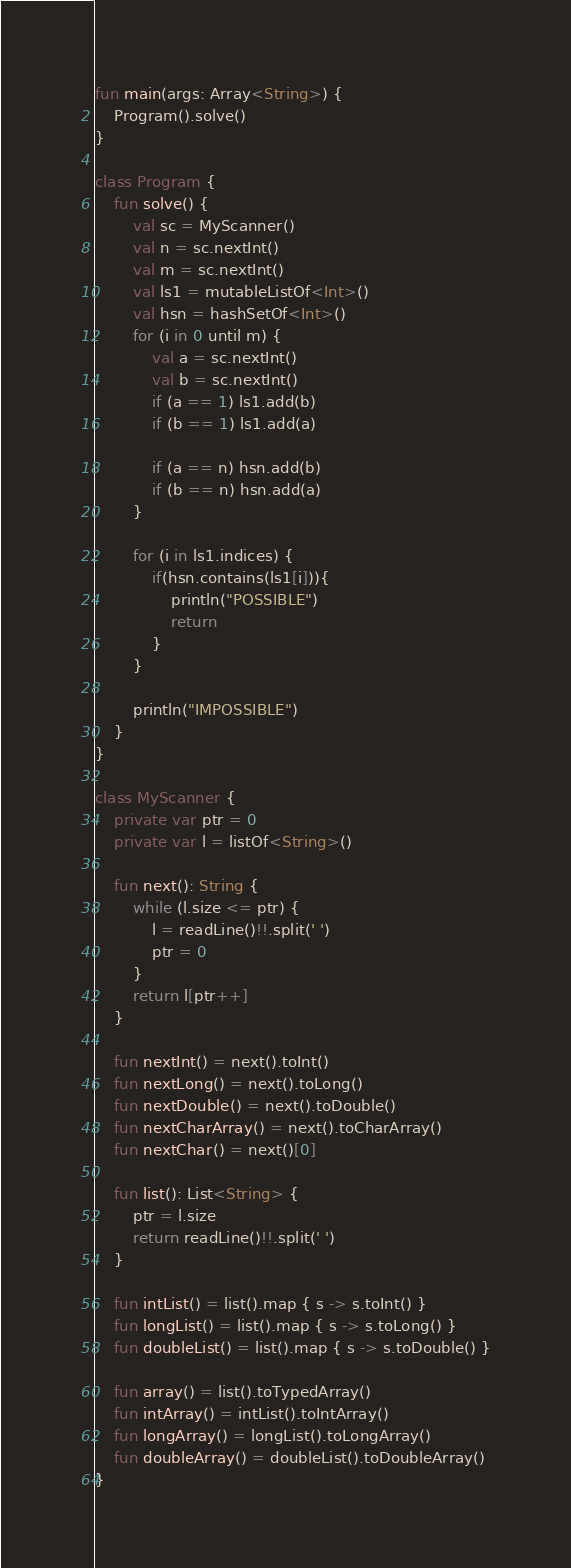<code> <loc_0><loc_0><loc_500><loc_500><_Kotlin_>fun main(args: Array<String>) {
    Program().solve()
}

class Program {
    fun solve() {
        val sc = MyScanner()
        val n = sc.nextInt()
        val m = sc.nextInt()
        val ls1 = mutableListOf<Int>()
        val hsn = hashSetOf<Int>()
        for (i in 0 until m) {
            val a = sc.nextInt()
            val b = sc.nextInt()
            if (a == 1) ls1.add(b)
            if (b == 1) ls1.add(a)

            if (a == n) hsn.add(b)
            if (b == n) hsn.add(a)
        }

        for (i in ls1.indices) {
            if(hsn.contains(ls1[i])){
                println("POSSIBLE")
                return
            }
        }

        println("IMPOSSIBLE")
    }
}

class MyScanner {
    private var ptr = 0
    private var l = listOf<String>()

    fun next(): String {
        while (l.size <= ptr) {
            l = readLine()!!.split(' ')
            ptr = 0
        }
        return l[ptr++]
    }

    fun nextInt() = next().toInt()
    fun nextLong() = next().toLong()
    fun nextDouble() = next().toDouble()
    fun nextCharArray() = next().toCharArray()
    fun nextChar() = next()[0]

    fun list(): List<String> {
        ptr = l.size
        return readLine()!!.split(' ')
    }

    fun intList() = list().map { s -> s.toInt() }
    fun longList() = list().map { s -> s.toLong() }
    fun doubleList() = list().map { s -> s.toDouble() }

    fun array() = list().toTypedArray()
    fun intArray() = intList().toIntArray()
    fun longArray() = longList().toLongArray()
    fun doubleArray() = doubleList().toDoubleArray()
}
</code> 